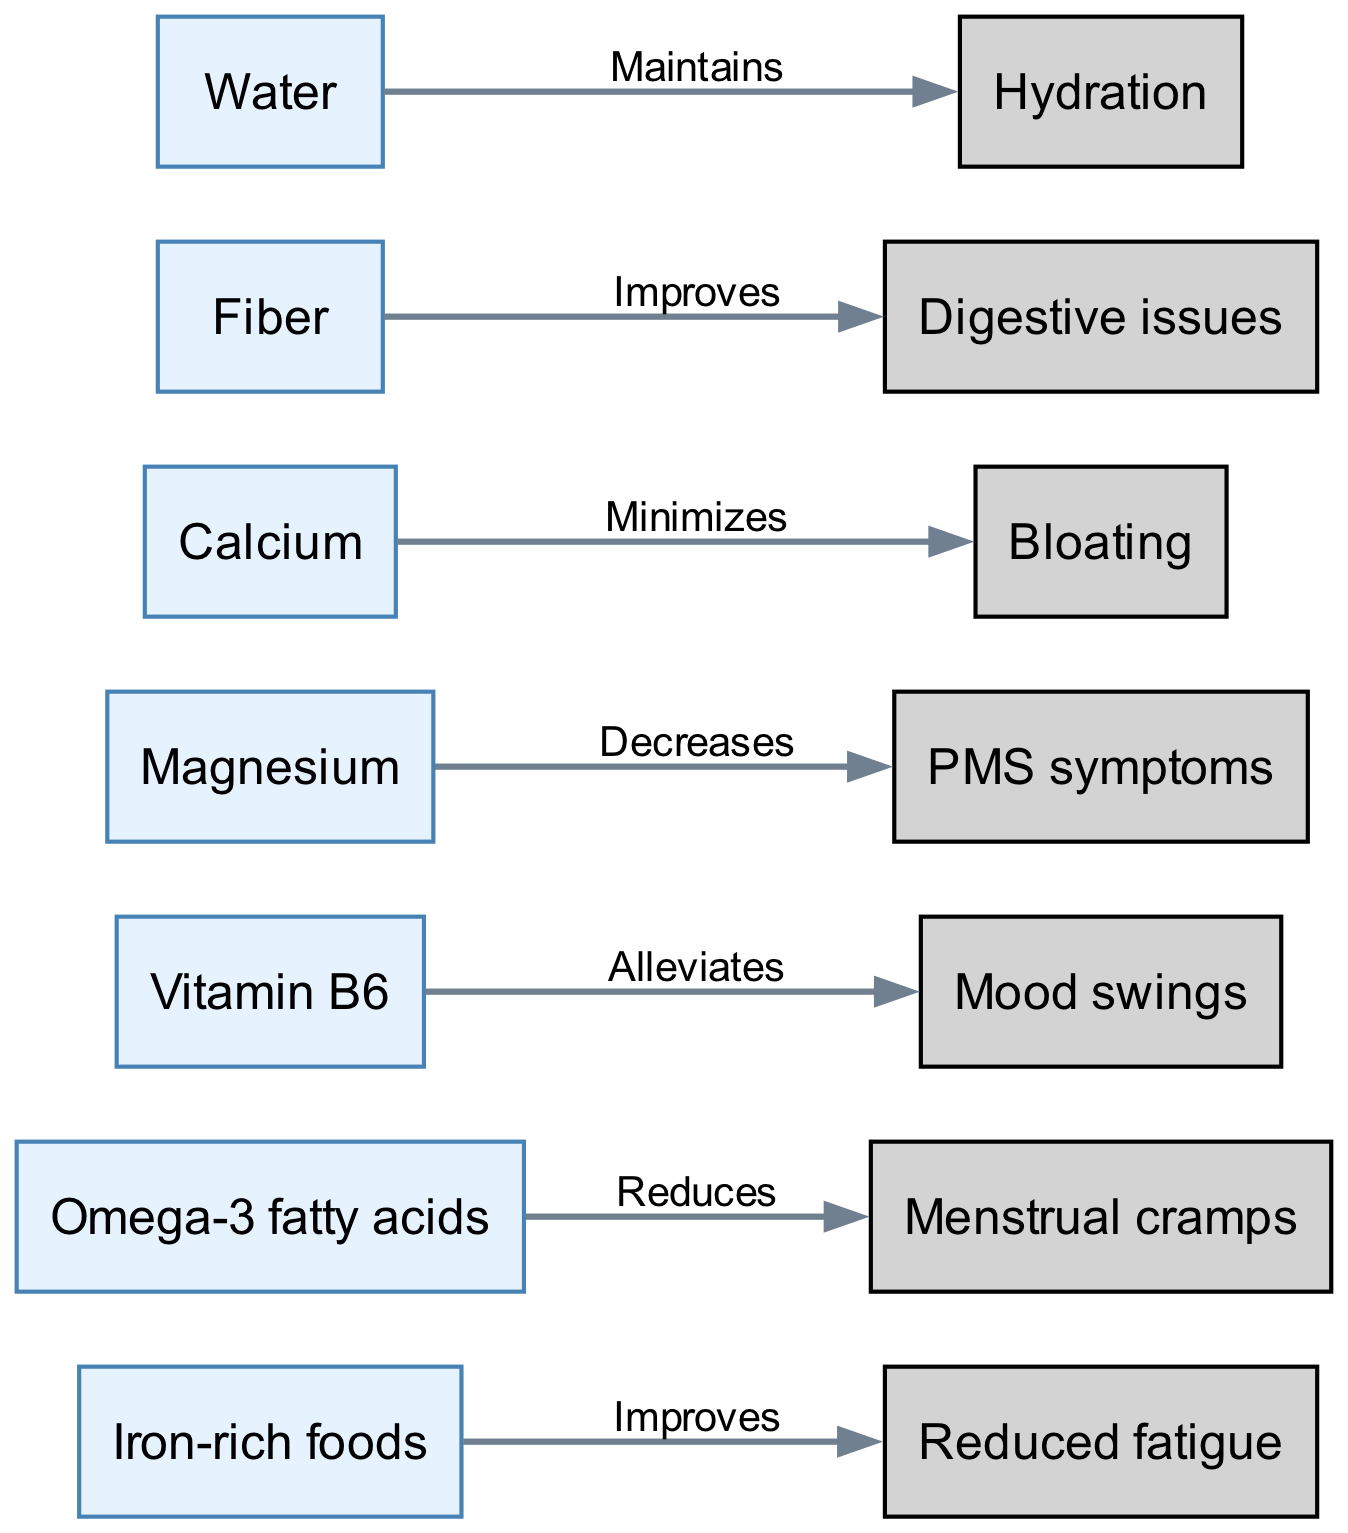What are the effects of Iron-rich foods? The diagram shows that Iron-rich foods improve reduced fatigue. Therefore, the effect is specifically mentioned related to reduced fatigue.
Answer: Reduced fatigue Which food reduces menstrual cramps? Looking at the diagram, Omega-3 fatty acids are directed towards menstrual cramps with a label that indicates it reduces that condition.
Answer: Omega-3 fatty acids How many nodes are there in total? By counting the nodes listed in the diagram, we find that there are 7 distinct nodes representing food or nutrients.
Answer: 7 What relationship does Magnesium have with PMS symptoms? The diagram indicates that Magnesium decreases PMS symptoms, showing a direct influence from the Magnesium node to the PMS symptoms node.
Answer: Decreases Which nutritional element is associated with minimizing bloating? The diagram demonstrates that Calcium is directly linked to minimizing bloating, pointing out its specific effect on that issue.
Answer: Calcium What role does Water have in this nutritional recommendation diagram? According to the diagram, Water maintains hydration, which is its specific role illustrated in the graph.
Answer: Maintains Which two foods positively connect to digestive issues? Reviewing the connections in the diagram, Fiber improves digestive issues while no other food is shown to connect to this concept, indicating Fiber as the sole food.
Answer: Fiber Determine the total number of directed edges in the diagram. By analyzing the connections presented in the diagram, there are a total of 7 directed edges that illustrate the relationships between the foods and their effects.
Answer: 7 What is the common connection between Vitamin B6 and mood swings? The directed graph establishes that Vitamin B6 alleviates mood swings, showing a straight positive influence.
Answer: Alleviates 